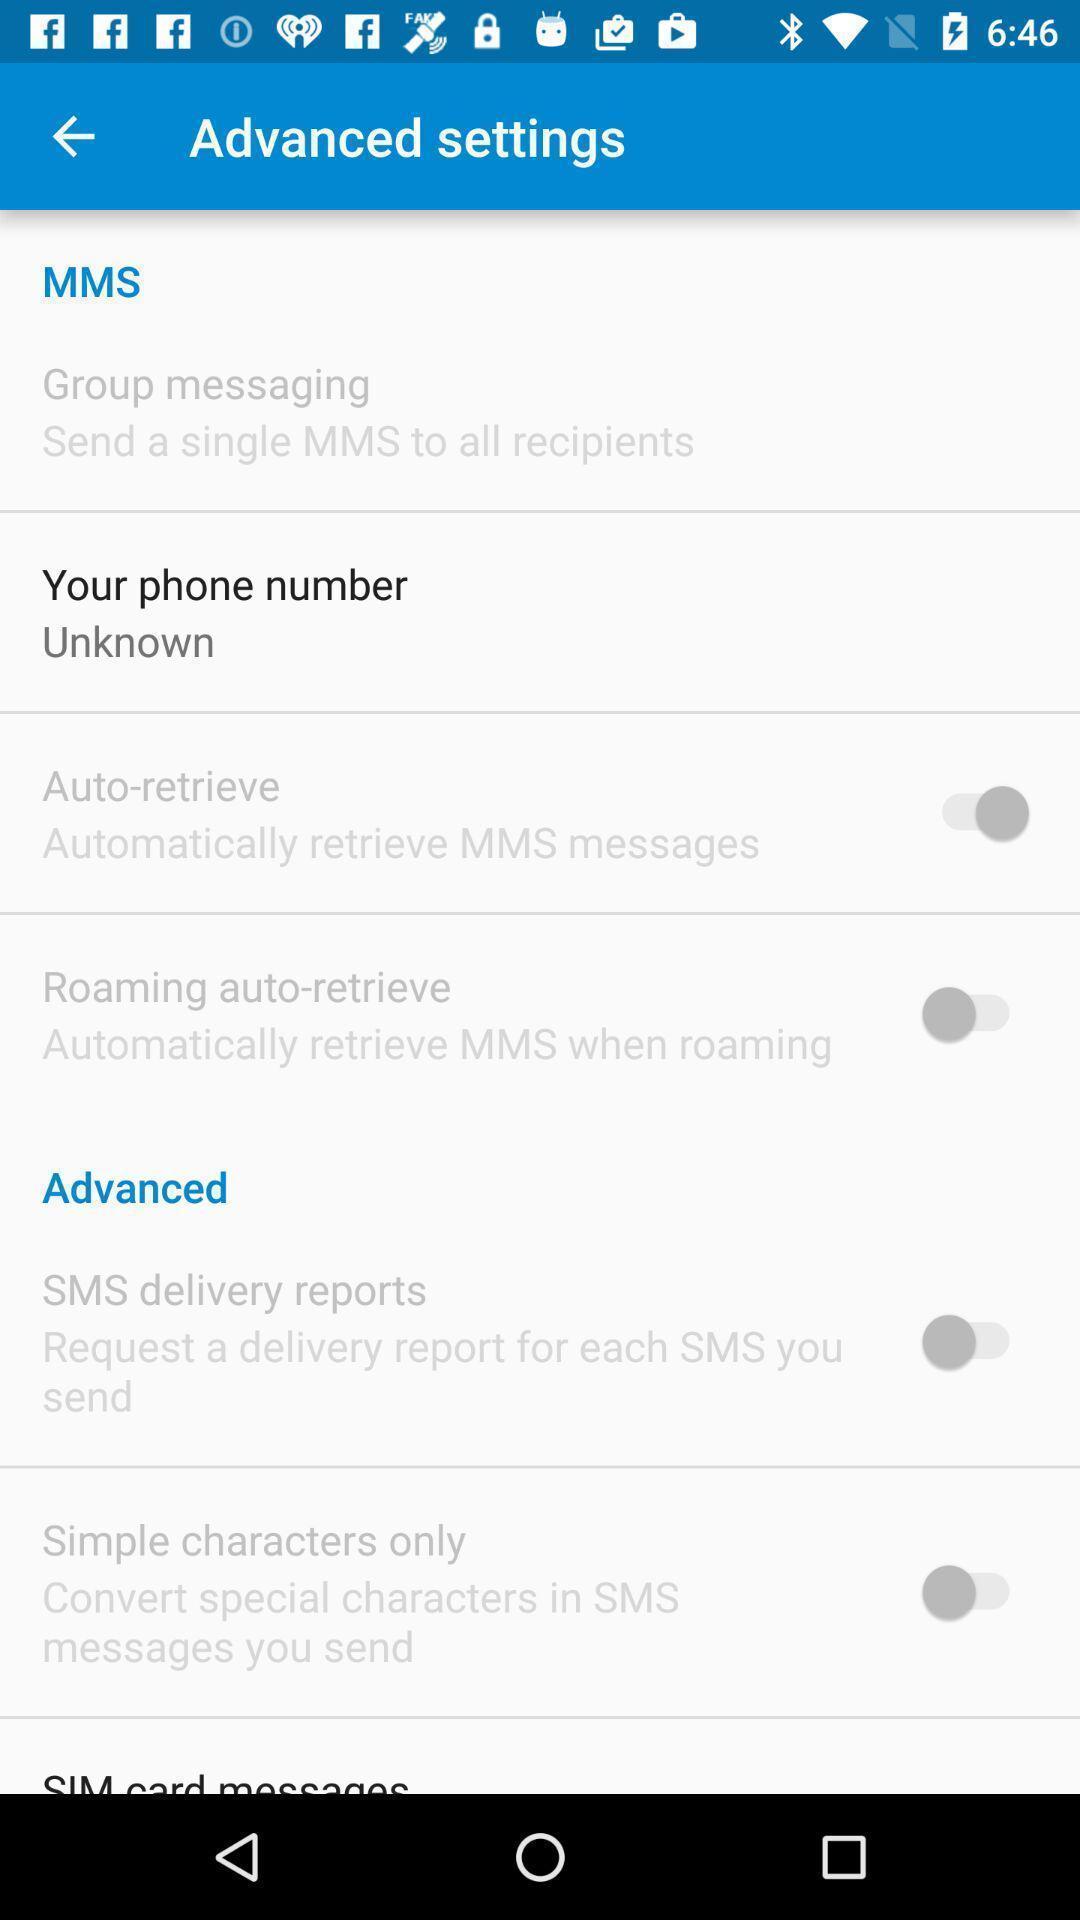What details can you identify in this image? Settings page. 